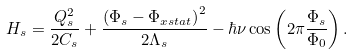<formula> <loc_0><loc_0><loc_500><loc_500>H _ { s } = \frac { Q _ { s } ^ { 2 } } { 2 C _ { s } } + \frac { \left ( \Phi _ { s } - \Phi _ { x s t a t } \right ) ^ { 2 } } { 2 \Lambda _ { s } } - \hbar { \nu } \cos \left ( 2 \pi \frac { \Phi _ { s } } { \Phi _ { 0 } } \right ) .</formula> 